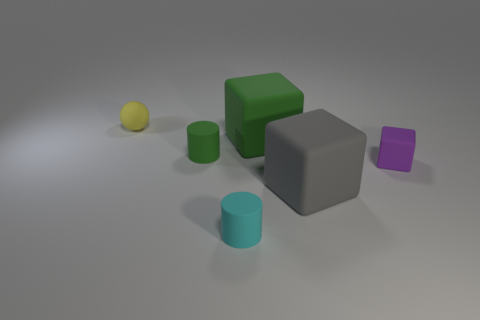Is there a thing that is right of the tiny matte cylinder that is left of the matte cylinder to the right of the small green cylinder? Yes, there is an object to the right of the tiny matte cylinder. It appears to be a small, matte purple cube, positioned left of the larger matte cylinder that is to the right of the small green cylinder. 